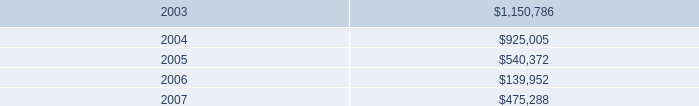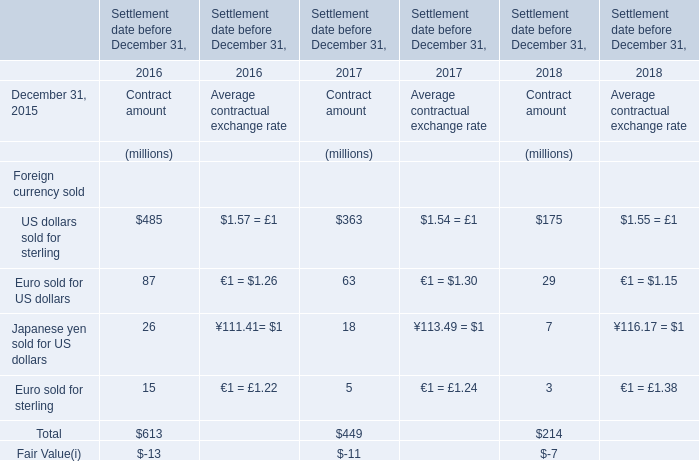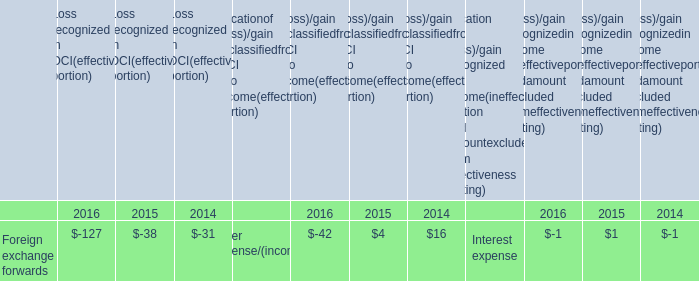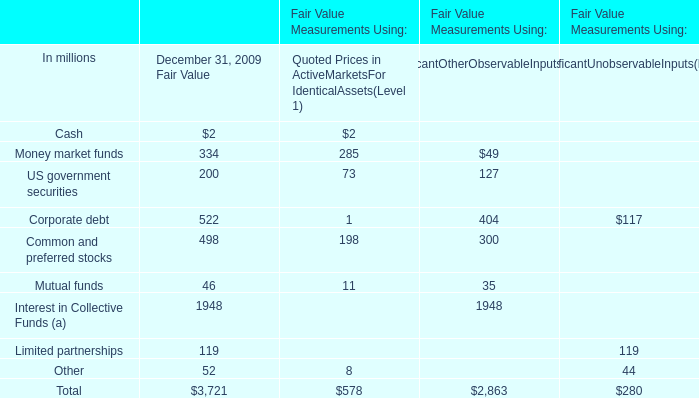How many Contract amount exceed the average of Contract amount in 2017? 
Answer: 1. 